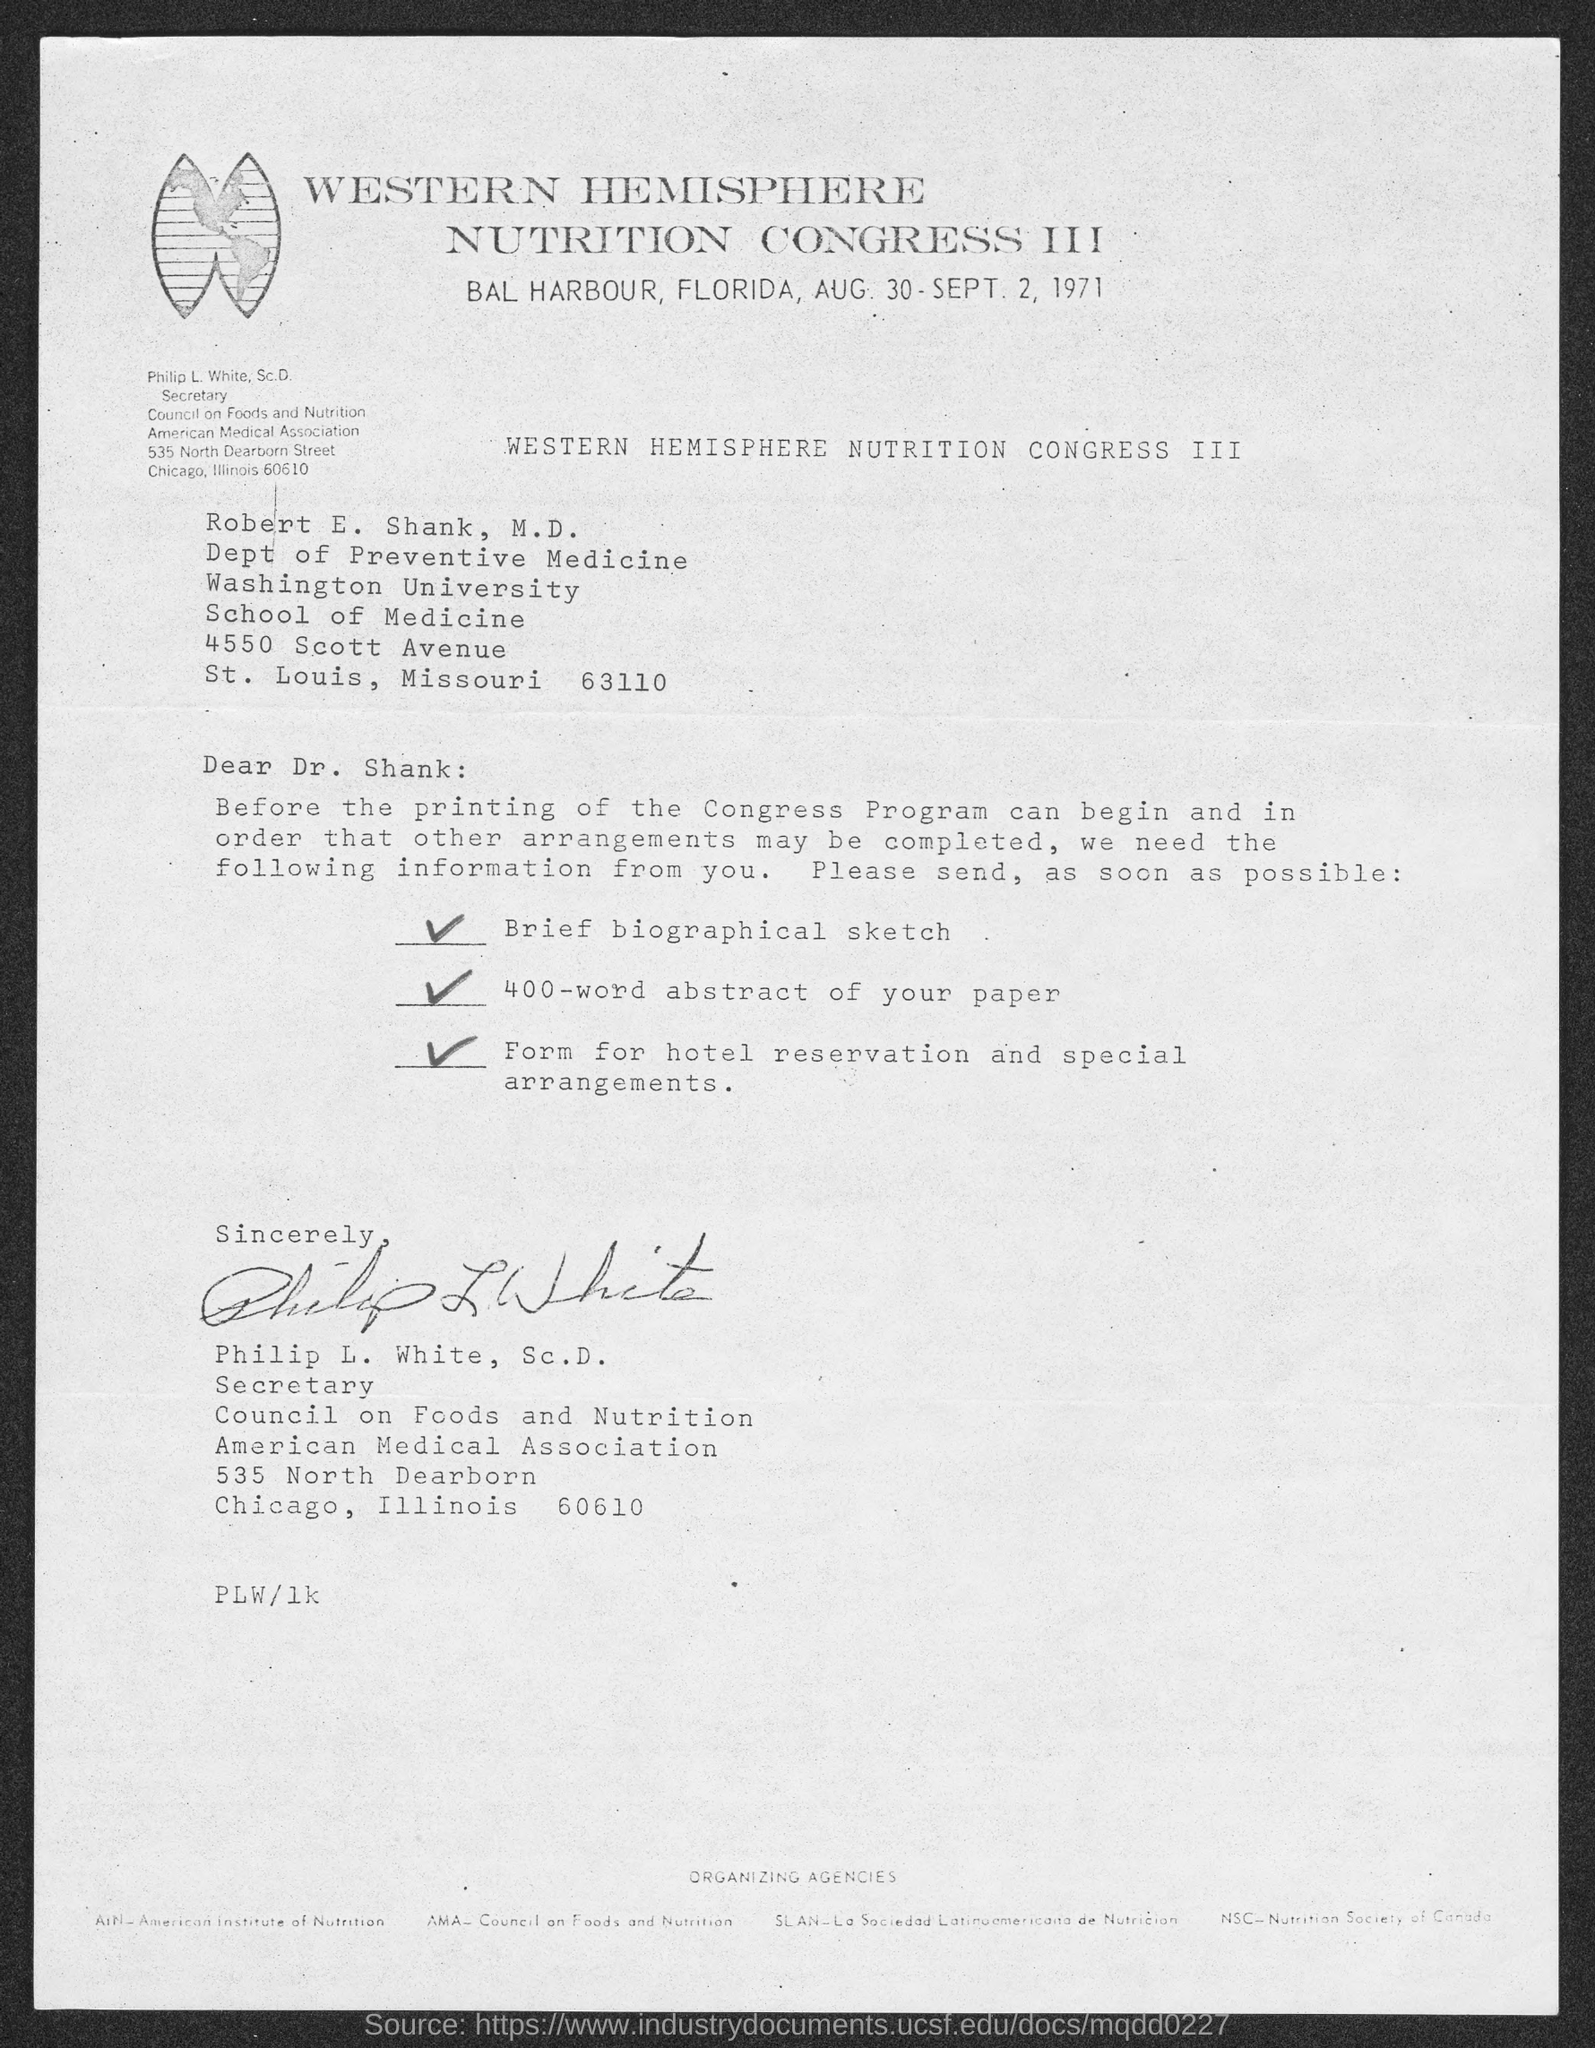Highlight a few significant elements in this photo. The Western Hemisphere Nutrition Congress III took place in 1971. The letter is addressed to Robert E. Shank, M.D. The Western Hemisphere Nutrition Congress III took place in Bal Harbour, Florida. 